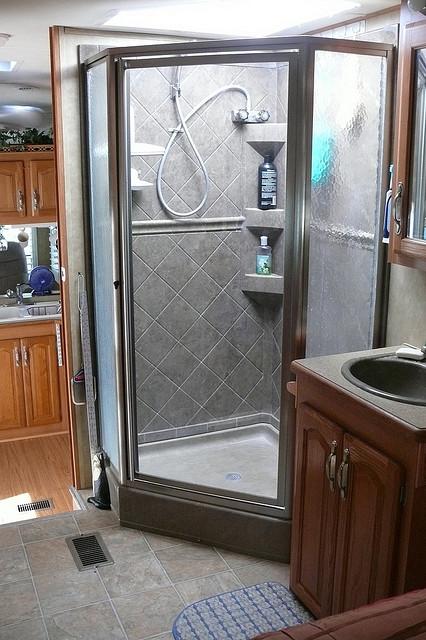What material is the sink?
Keep it brief. Metal. How many bottles are in the shower?
Concise answer only. 2. What is the floor made of?
Answer briefly. Tile. 